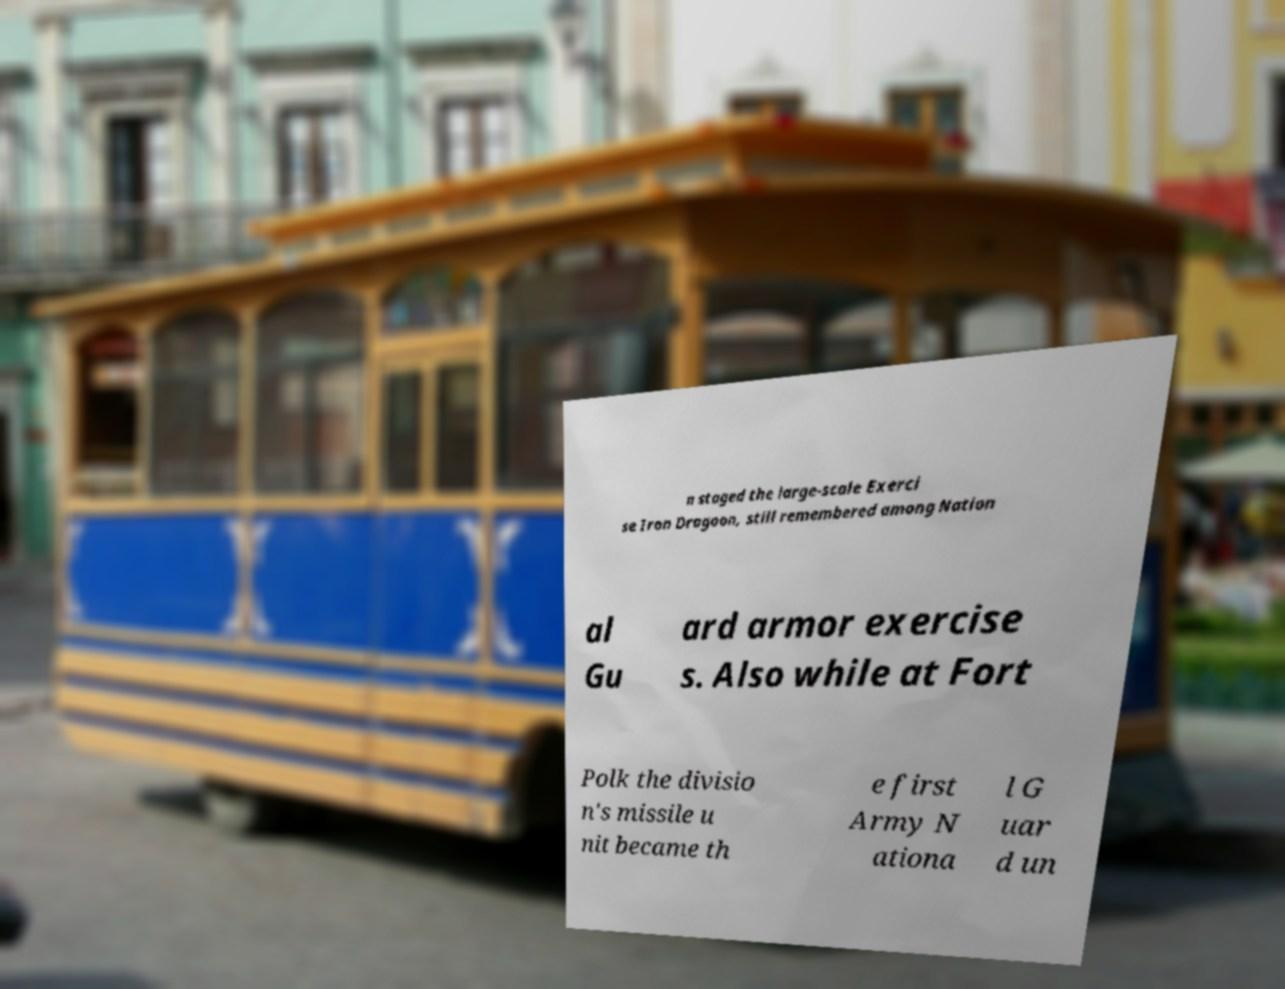There's text embedded in this image that I need extracted. Can you transcribe it verbatim? n staged the large-scale Exerci se Iron Dragoon, still remembered among Nation al Gu ard armor exercise s. Also while at Fort Polk the divisio n's missile u nit became th e first Army N ationa l G uar d un 